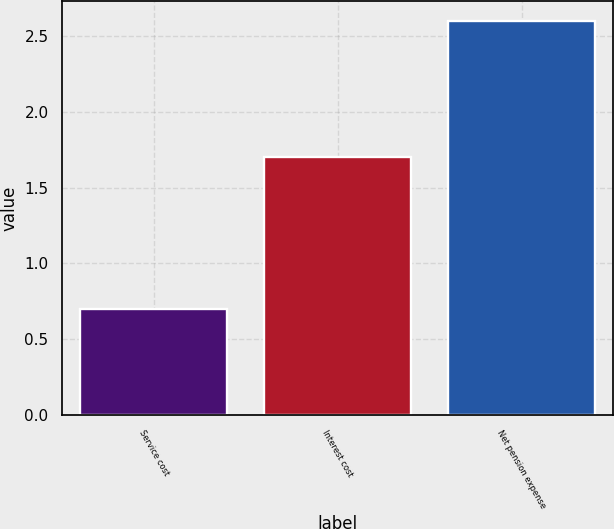Convert chart. <chart><loc_0><loc_0><loc_500><loc_500><bar_chart><fcel>Service cost<fcel>Interest cost<fcel>Net pension expense<nl><fcel>0.7<fcel>1.7<fcel>2.6<nl></chart> 